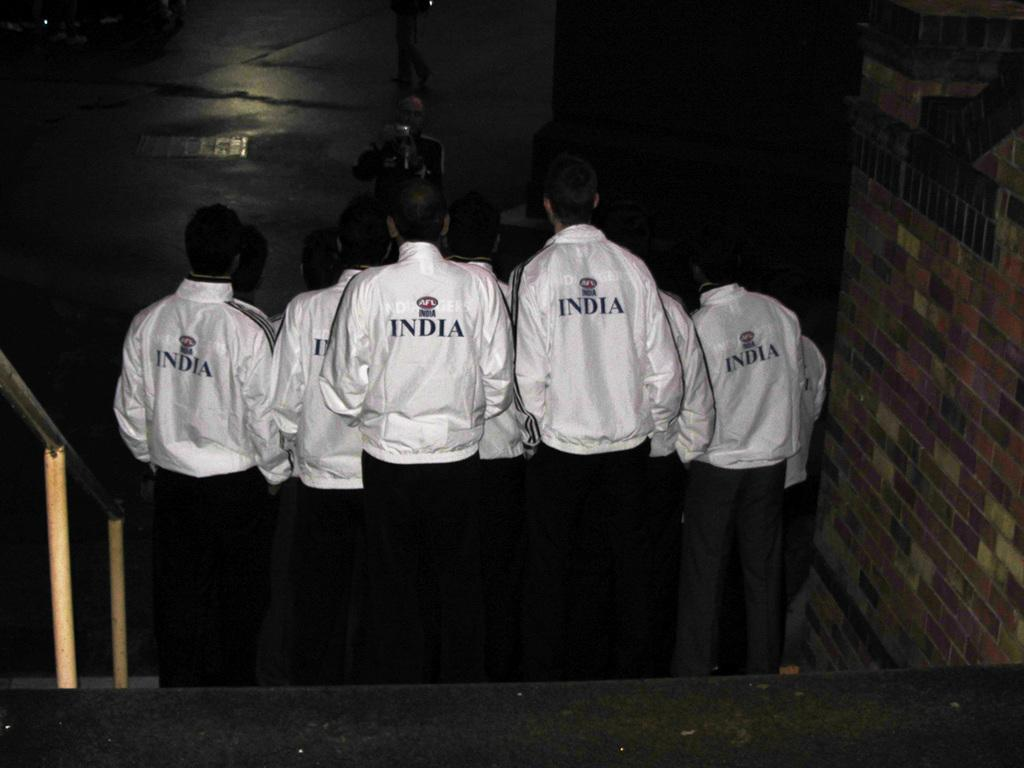<image>
Relay a brief, clear account of the picture shown. A group of boys are walking down steps and their white jackets all say India. 